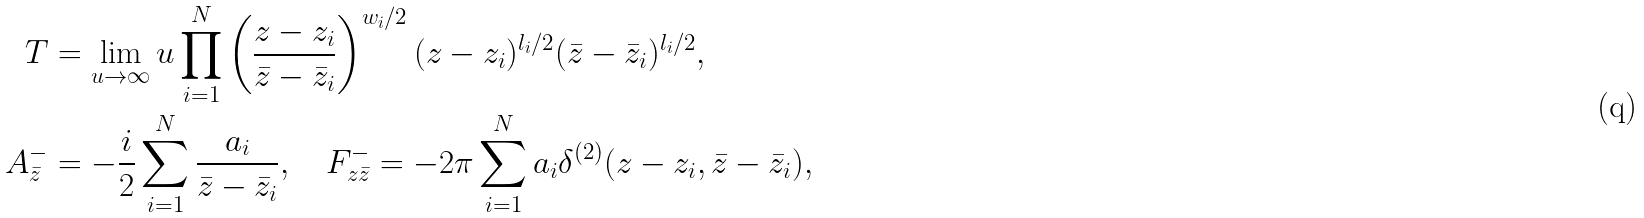<formula> <loc_0><loc_0><loc_500><loc_500>T & = \lim _ { u \to \infty } u \prod _ { i = 1 } ^ { N } \left ( \frac { z - z _ { i } } { \bar { z } - \bar { z } _ { i } } \right ) ^ { w _ { i } / 2 } ( z - z _ { i } ) ^ { l _ { i } / 2 } ( \bar { z } - \bar { z } _ { i } ) ^ { l _ { i } / 2 } , \\ A ^ { - } _ { \bar { z } } & = - \frac { i } { 2 } \sum _ { i = 1 } ^ { N } \frac { a _ { i } } { \bar { z } - \bar { z } _ { i } } , \quad F ^ { - } _ { z \bar { z } } = - 2 \pi \sum _ { i = 1 } ^ { N } a _ { i } \delta ^ { ( 2 ) } ( z - z _ { i } , \bar { z } - \bar { z } _ { i } ) ,</formula> 